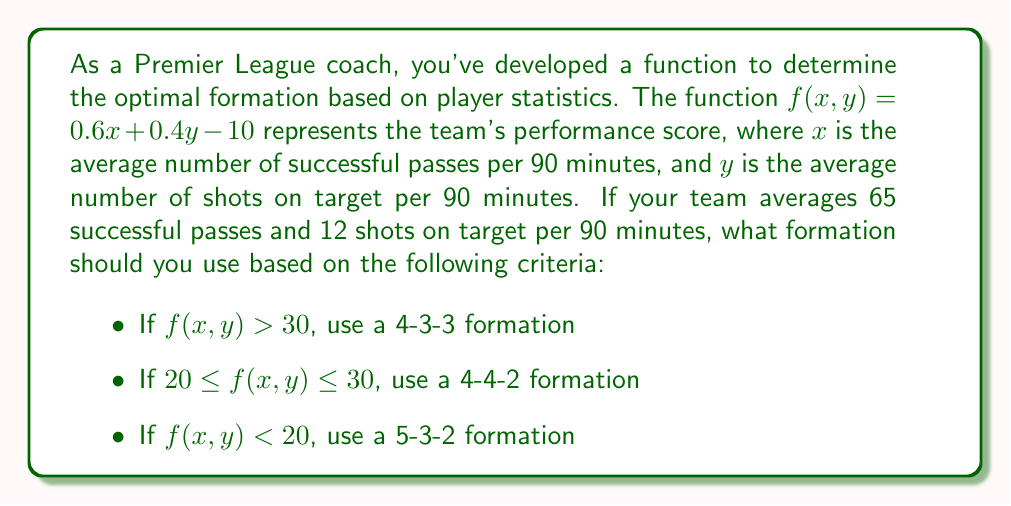Provide a solution to this math problem. Let's approach this step-by-step:

1) We're given the function $f(x, y) = 0.6x + 0.4y - 10$

2) We know that:
   $x = 65$ (average successful passes per 90 minutes)
   $y = 12$ (average shots on target per 90 minutes)

3) Let's substitute these values into our function:

   $f(65, 12) = 0.6(65) + 0.4(12) - 10$

4) Now let's calculate:

   $f(65, 12) = 39 + 4.8 - 10$
   $f(65, 12) = 43.8 - 10$
   $f(65, 12) = 33.8$

5) Now we compare this result to the given criteria:

   $f(x, y) = 33.8$, which is greater than 30

6) Based on the criteria, if $f(x, y) > 30$, we should use a 4-3-3 formation.
Answer: 4-3-3 formation 